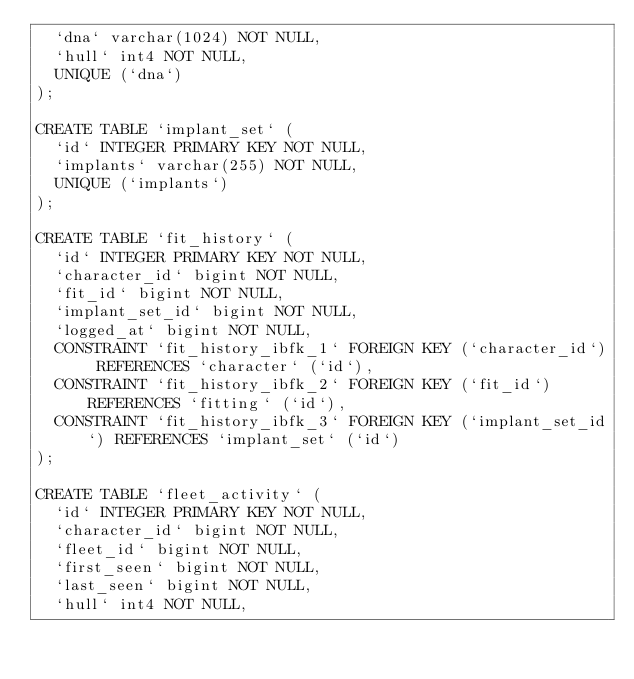<code> <loc_0><loc_0><loc_500><loc_500><_SQL_>  `dna` varchar(1024) NOT NULL,
  `hull` int4 NOT NULL,
  UNIQUE (`dna`)
);

CREATE TABLE `implant_set` (
  `id` INTEGER PRIMARY KEY NOT NULL,
  `implants` varchar(255) NOT NULL,
  UNIQUE (`implants`)
);

CREATE TABLE `fit_history` (
  `id` INTEGER PRIMARY KEY NOT NULL,
  `character_id` bigint NOT NULL,
  `fit_id` bigint NOT NULL,
  `implant_set_id` bigint NOT NULL,
  `logged_at` bigint NOT NULL,
  CONSTRAINT `fit_history_ibfk_1` FOREIGN KEY (`character_id`) REFERENCES `character` (`id`),
  CONSTRAINT `fit_history_ibfk_2` FOREIGN KEY (`fit_id`) REFERENCES `fitting` (`id`),
  CONSTRAINT `fit_history_ibfk_3` FOREIGN KEY (`implant_set_id`) REFERENCES `implant_set` (`id`)
);

CREATE TABLE `fleet_activity` (
  `id` INTEGER PRIMARY KEY NOT NULL,
  `character_id` bigint NOT NULL,
  `fleet_id` bigint NOT NULL,
  `first_seen` bigint NOT NULL,
  `last_seen` bigint NOT NULL,
  `hull` int4 NOT NULL,</code> 